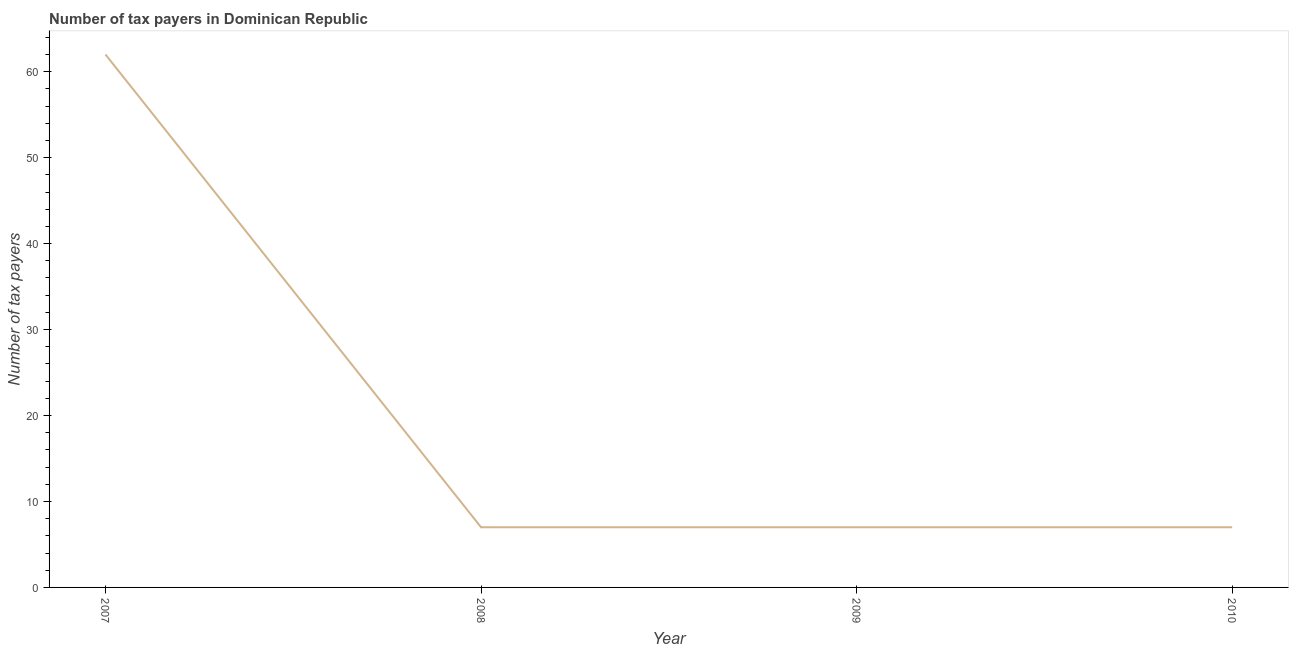What is the number of tax payers in 2009?
Ensure brevity in your answer.  7. Across all years, what is the maximum number of tax payers?
Provide a succinct answer. 62. Across all years, what is the minimum number of tax payers?
Offer a very short reply. 7. In which year was the number of tax payers minimum?
Offer a very short reply. 2008. What is the sum of the number of tax payers?
Your response must be concise. 83. What is the difference between the number of tax payers in 2007 and 2009?
Provide a succinct answer. 55. What is the average number of tax payers per year?
Ensure brevity in your answer.  20.75. What is the median number of tax payers?
Offer a very short reply. 7. What is the ratio of the number of tax payers in 2008 to that in 2009?
Your answer should be very brief. 1. Is the sum of the number of tax payers in 2008 and 2010 greater than the maximum number of tax payers across all years?
Your answer should be very brief. No. What is the difference between the highest and the lowest number of tax payers?
Give a very brief answer. 55. In how many years, is the number of tax payers greater than the average number of tax payers taken over all years?
Offer a terse response. 1. Does the number of tax payers monotonically increase over the years?
Make the answer very short. No. How many lines are there?
Provide a succinct answer. 1. How many years are there in the graph?
Make the answer very short. 4. What is the difference between two consecutive major ticks on the Y-axis?
Keep it short and to the point. 10. Are the values on the major ticks of Y-axis written in scientific E-notation?
Offer a very short reply. No. Does the graph contain any zero values?
Provide a succinct answer. No. What is the title of the graph?
Make the answer very short. Number of tax payers in Dominican Republic. What is the label or title of the Y-axis?
Your answer should be compact. Number of tax payers. What is the Number of tax payers in 2010?
Provide a short and direct response. 7. What is the difference between the Number of tax payers in 2007 and 2010?
Ensure brevity in your answer.  55. What is the ratio of the Number of tax payers in 2007 to that in 2008?
Provide a succinct answer. 8.86. What is the ratio of the Number of tax payers in 2007 to that in 2009?
Give a very brief answer. 8.86. What is the ratio of the Number of tax payers in 2007 to that in 2010?
Keep it short and to the point. 8.86. What is the ratio of the Number of tax payers in 2008 to that in 2009?
Offer a very short reply. 1. What is the ratio of the Number of tax payers in 2008 to that in 2010?
Your response must be concise. 1. 